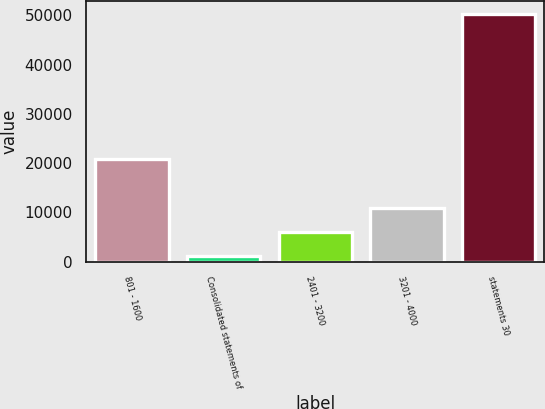Convert chart to OTSL. <chart><loc_0><loc_0><loc_500><loc_500><bar_chart><fcel>801 - 1600<fcel>Consolidated statements of<fcel>2401 - 3200<fcel>3201 - 4000<fcel>statements 30<nl><fcel>20801.6<fcel>1146<fcel>6059.9<fcel>10973.8<fcel>50285<nl></chart> 